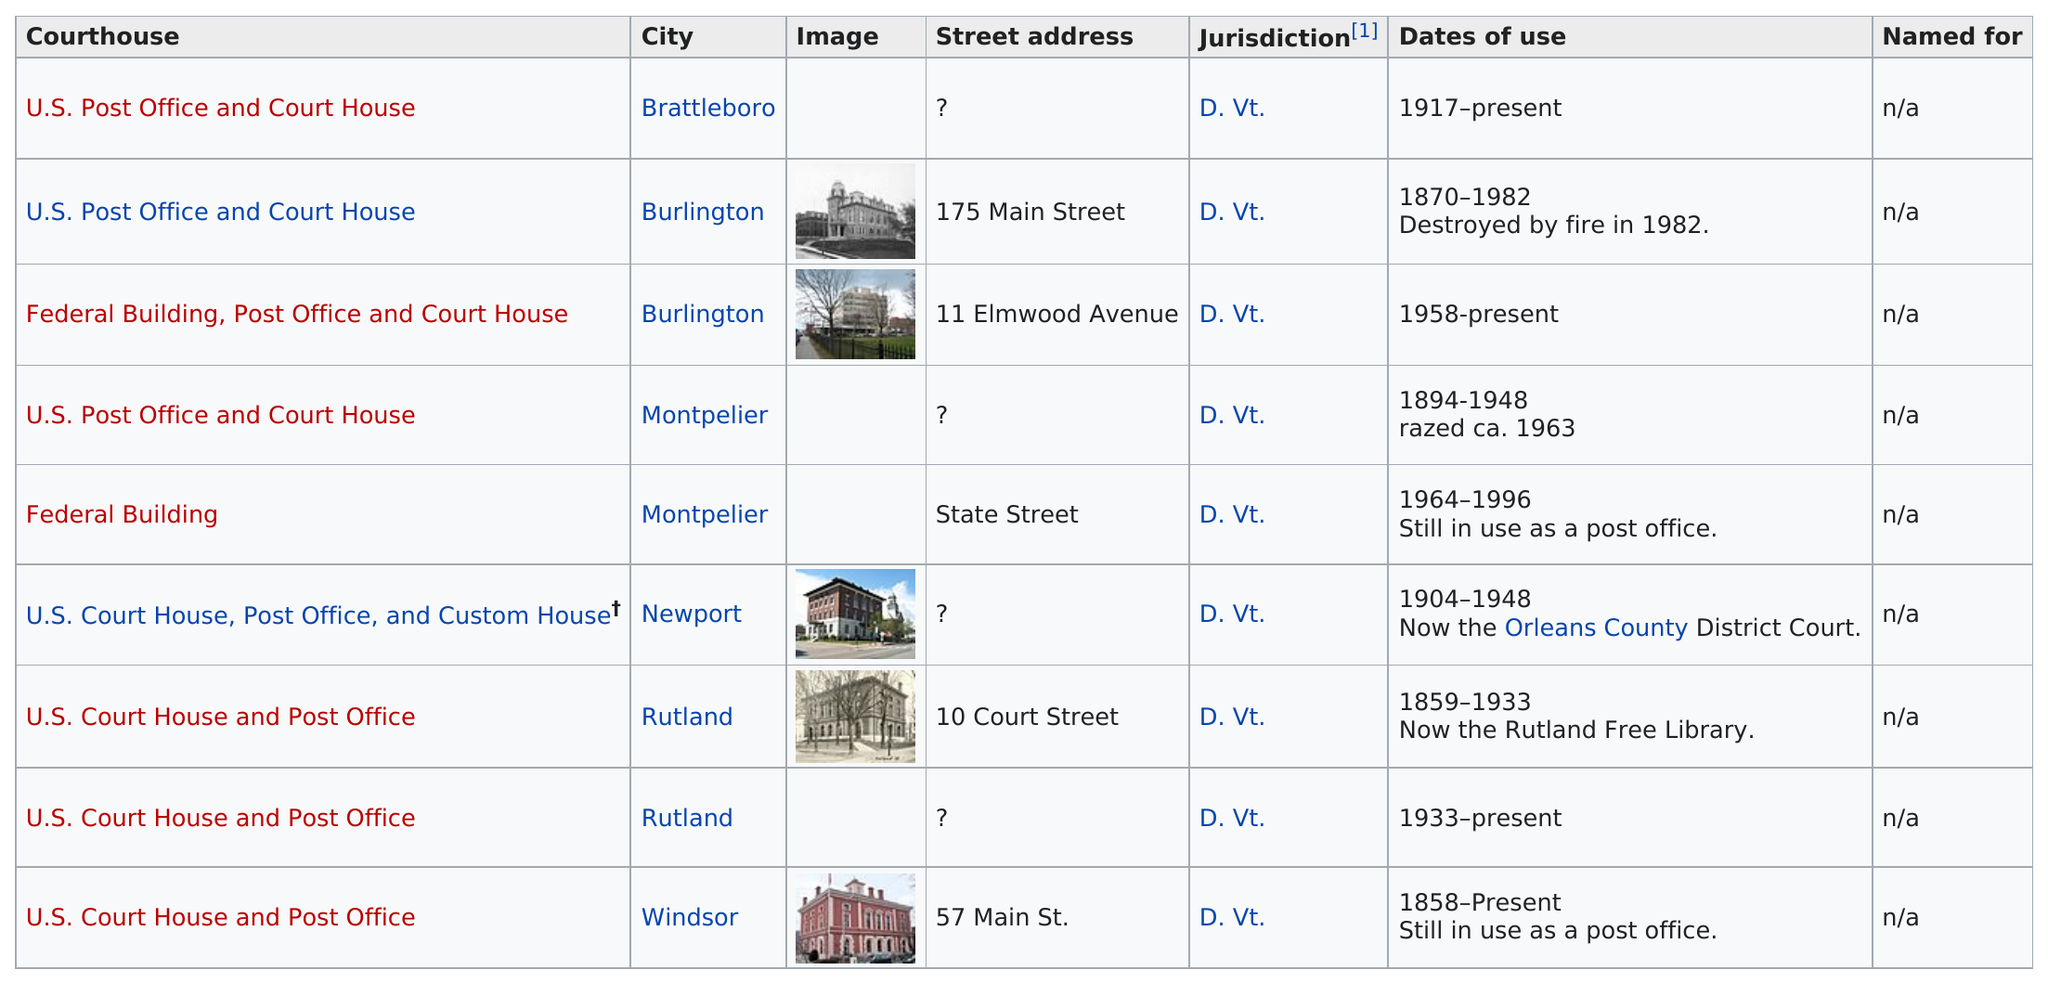Draw attention to some important aspects in this diagram. The first court house was built in Windsor. Montpelier has two courthouses. The Burlington courthouse is the only one to have been destroyed by fire. Two of the courthouses in Vermont are federal buildings. The city of Brattleboro's courthouse has been in use for 97 years. 